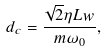<formula> <loc_0><loc_0><loc_500><loc_500>d _ { c } = \frac { \sqrt { 2 } \eta L w } { m \omega _ { 0 } } ,</formula> 